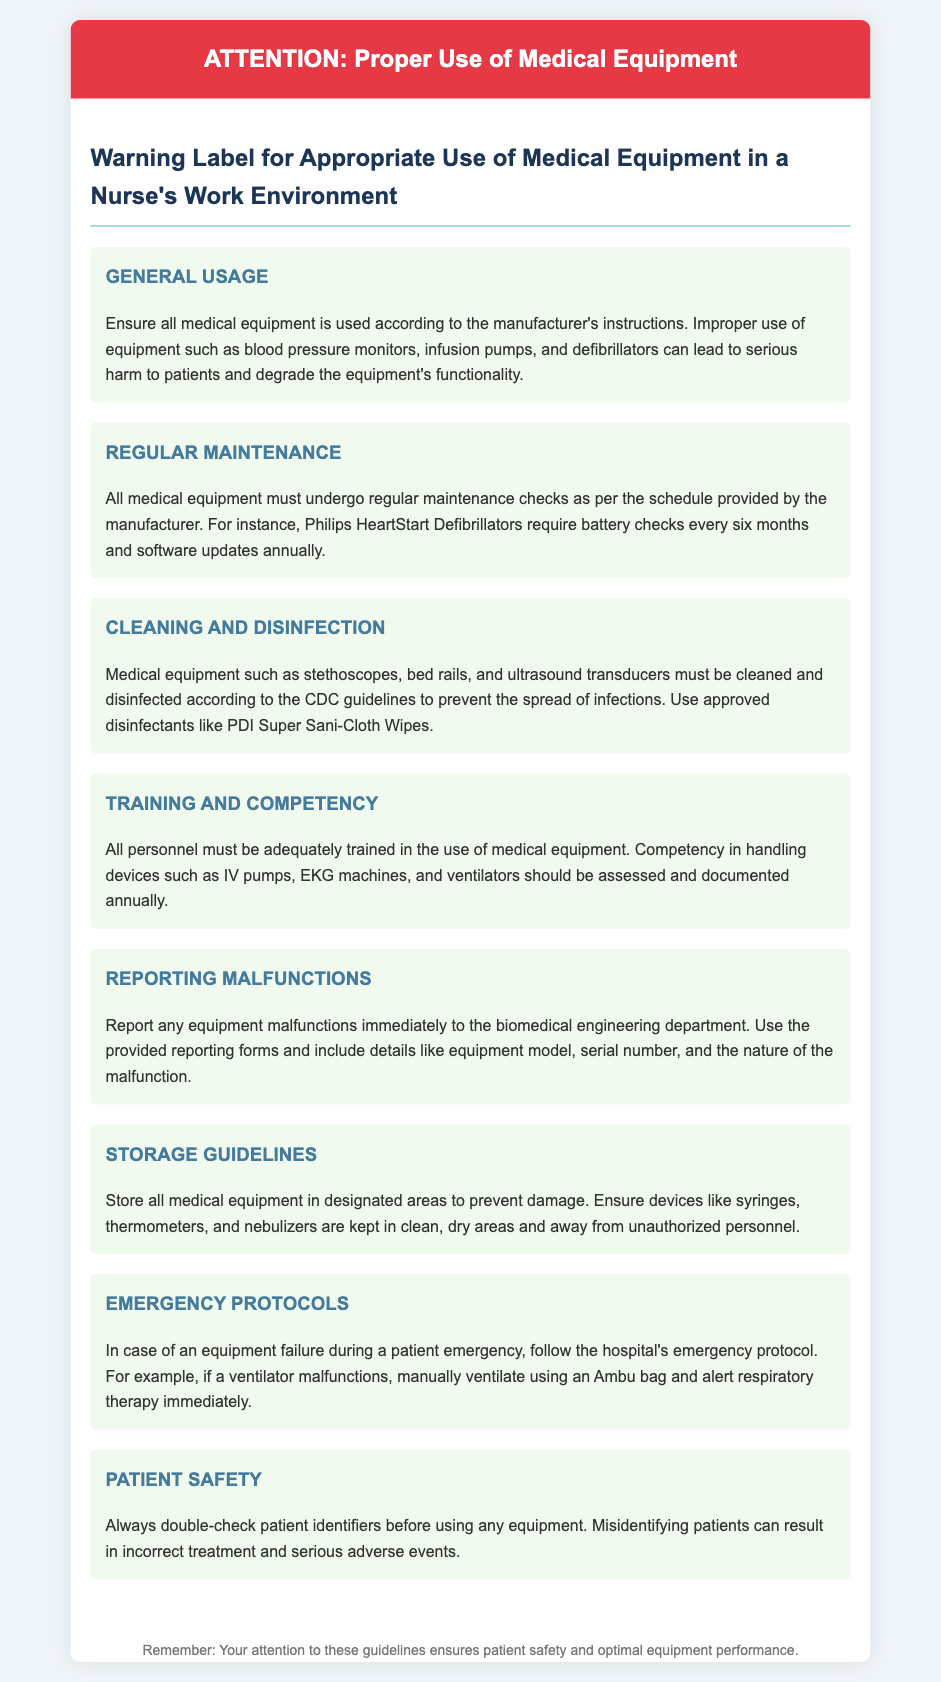What is the title of the warning label? The title of the warning label is stated at the top of the document, providing clear guidance on its purpose.
Answer: Warning Label for Appropriate Use of Medical Equipment in a Nurse's Work Environment How often should Philips HeartStart Defibrillators have battery checks? The specific frequency for battery checks of the Philips HeartStart Defibrillators is highlighted in the maintenance section.
Answer: every six months What should you use to clean medical equipment according to CDC guidelines? The document specifies the approved disinfectant to be used for cleaning medical equipment, indicating proper hygiene practices.
Answer: PDI Super Sani-Cloth Wipes What must personnel demonstrate annually for equipment handling? The document indicates the requirement for assessment and documentation, ensuring competency among personnel using equipment.
Answer: competency What should be reported to the biomedical engineering department? The document emphasizes the necessity of reporting specific issues to ensure prompt attention to equipment safety.
Answer: equipment malfunctions What is a step to take if a ventilator fails during an emergency? The emergency protocols section outlines the immediate action to take for handling equipment failure in critical situations.
Answer: manually ventilate using an Ambu bag What type of areas should medical equipment be stored in? The document addresses storage guidelines that ensure the protection and accessibility of medical equipment.
Answer: designated areas What must be double-checked before using any equipment? The document highlights a critical safety procedure that helps prevent errors in patient care.
Answer: patient identifiers 